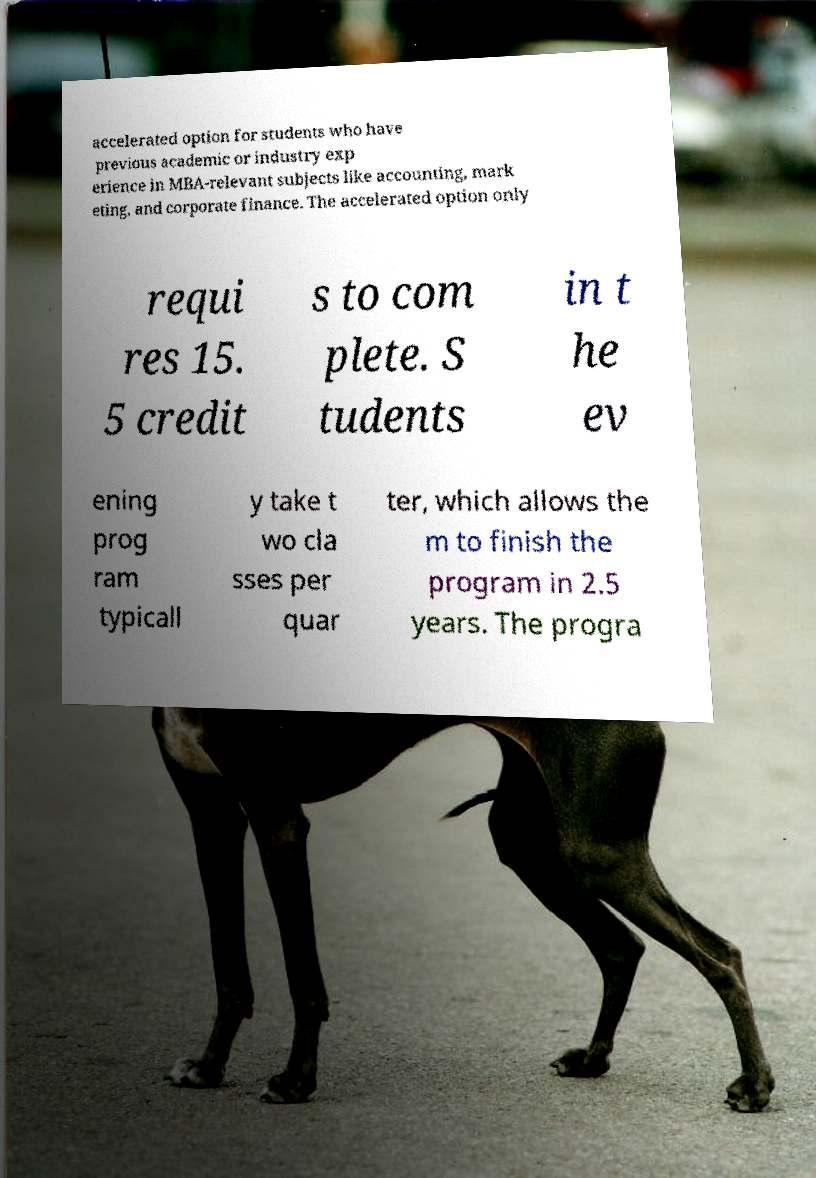For documentation purposes, I need the text within this image transcribed. Could you provide that? accelerated option for students who have previous academic or industry exp erience in MBA-relevant subjects like accounting, mark eting, and corporate finance. The accelerated option only requi res 15. 5 credit s to com plete. S tudents in t he ev ening prog ram typicall y take t wo cla sses per quar ter, which allows the m to finish the program in 2.5 years. The progra 